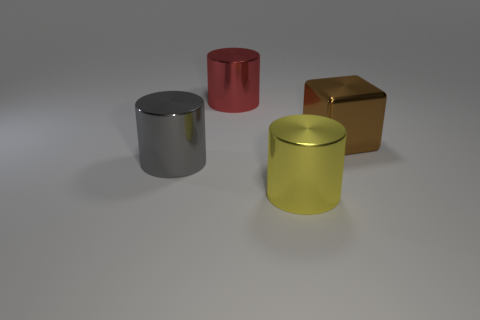Add 2 large yellow objects. How many objects exist? 6 Subtract all cylinders. How many objects are left? 1 Add 4 big cylinders. How many big cylinders are left? 7 Add 2 blue matte cubes. How many blue matte cubes exist? 2 Subtract 0 brown balls. How many objects are left? 4 Subtract all yellow objects. Subtract all brown metal objects. How many objects are left? 2 